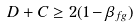Convert formula to latex. <formula><loc_0><loc_0><loc_500><loc_500>D + C \geq 2 ( 1 - \beta _ { f g } )</formula> 